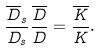<formula> <loc_0><loc_0><loc_500><loc_500>\frac { \overline { D } _ { s } } { { D } _ { s } } \frac { \overline { D } } { D } = \frac { \overline { K } } { K } .</formula> 